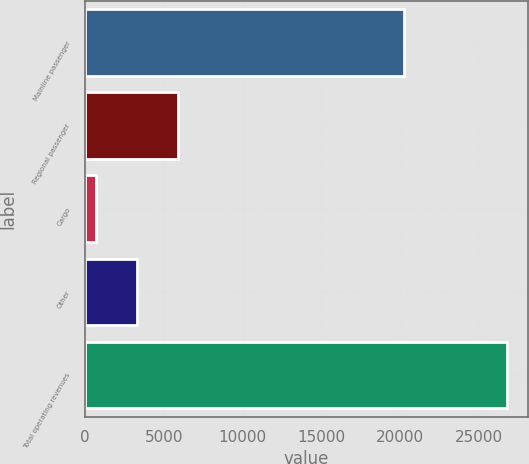<chart> <loc_0><loc_0><loc_500><loc_500><bar_chart><fcel>Mainline passenger<fcel>Regional passenger<fcel>Cargo<fcel>Other<fcel>Total operating revenues<nl><fcel>20218<fcel>5896.6<fcel>685<fcel>3290.8<fcel>26743<nl></chart> 